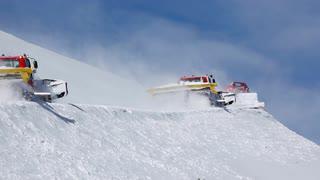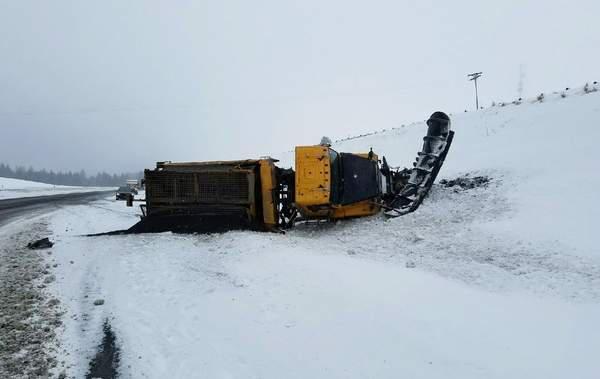The first image is the image on the left, the second image is the image on the right. Examine the images to the left and right. Is the description "there are two bulldozers facing the same direction" accurate? Answer yes or no. No. The first image is the image on the left, the second image is the image on the right. For the images displayed, is the sentence "The plow on the truck in the left image is yellow." factually correct? Answer yes or no. No. 